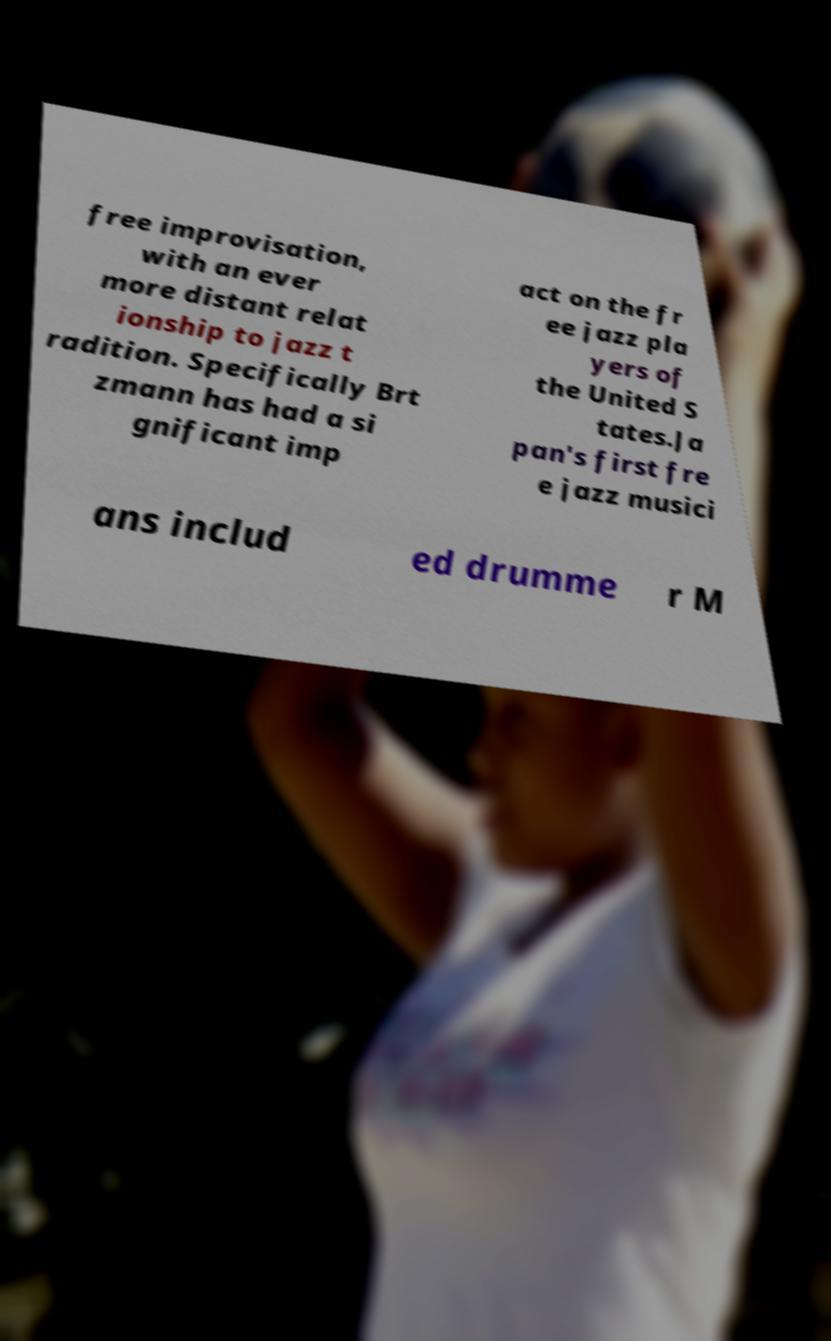Can you read and provide the text displayed in the image?This photo seems to have some interesting text. Can you extract and type it out for me? free improvisation, with an ever more distant relat ionship to jazz t radition. Specifically Brt zmann has had a si gnificant imp act on the fr ee jazz pla yers of the United S tates.Ja pan's first fre e jazz musici ans includ ed drumme r M 